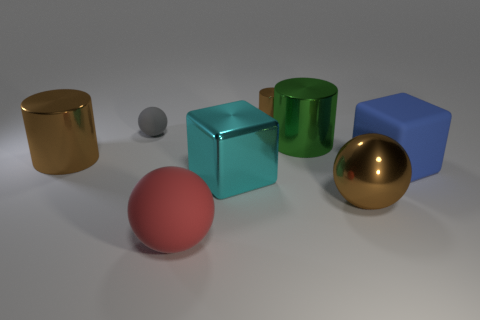How many other objects are there of the same color as the tiny shiny cylinder?
Provide a succinct answer. 2. The big blue cube that is in front of the tiny object on the left side of the large cyan shiny cube is made of what material?
Provide a succinct answer. Rubber. Are any large purple things visible?
Your response must be concise. No. There is a brown cylinder left of the big rubber object that is to the left of the blue matte cube; what size is it?
Offer a terse response. Large. Is the number of green shiny things that are behind the big brown ball greater than the number of big cylinders in front of the big blue cube?
Offer a very short reply. Yes. What number of blocks are large things or green metallic objects?
Your answer should be compact. 2. Are there any other things that have the same size as the brown metal ball?
Make the answer very short. Yes. Is the shape of the big matte object that is behind the big cyan metallic object the same as  the cyan metal object?
Provide a succinct answer. Yes. What is the color of the small shiny thing?
Give a very brief answer. Brown. What is the color of the other big thing that is the same shape as the big blue thing?
Offer a terse response. Cyan. 